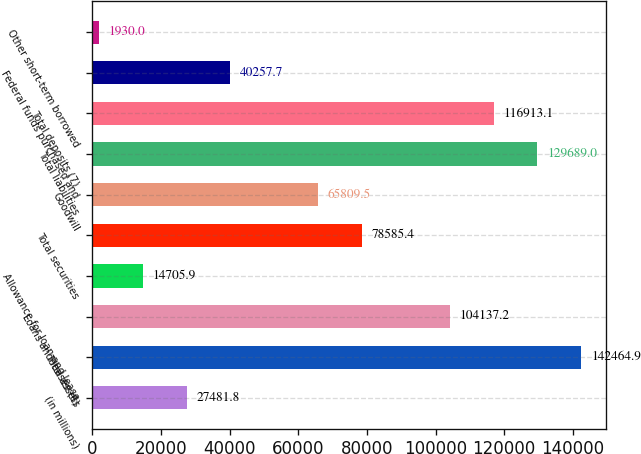Convert chart. <chart><loc_0><loc_0><loc_500><loc_500><bar_chart><fcel>(in millions)<fcel>Total assets<fcel>Loans and leases (6)<fcel>Allowance for loan and lease<fcel>Total securities<fcel>Goodwill<fcel>Total liabilities<fcel>Total deposits (7)<fcel>Federal funds purchased and<fcel>Other short-term borrowed<nl><fcel>27481.8<fcel>142465<fcel>104137<fcel>14705.9<fcel>78585.4<fcel>65809.5<fcel>129689<fcel>116913<fcel>40257.7<fcel>1930<nl></chart> 